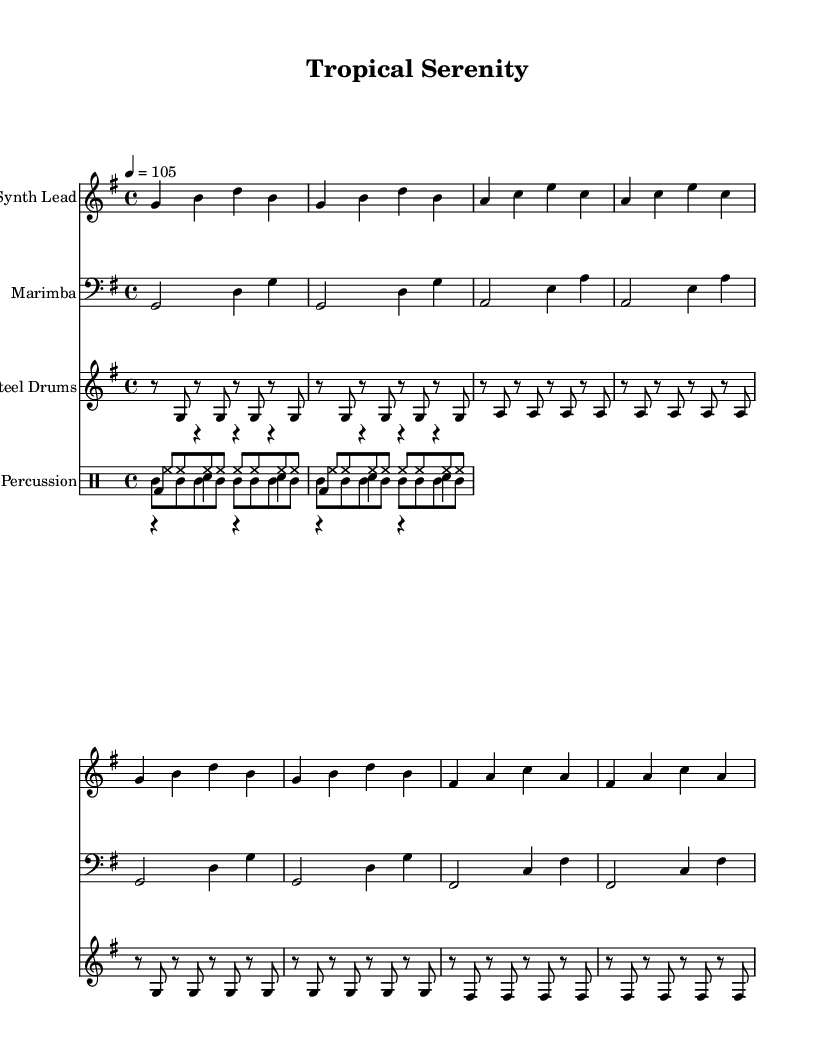What is the key signature of this music? The key signature is G major, which has one sharp (F-sharp). This can be determined by locating the key signature indicated at the beginning of the piece, right after the clef sign.
Answer: G major What is the time signature of this music? The time signature is 4/4, which is indicated at the start of the music after the key signature. This means there are four beats in each measure and the quarter note gets one beat.
Answer: 4/4 What is the tempo marking for this piece? The tempo marking is 4 = 105, which tells the performer to play at a speed of 105 beats per minute with a quarter note receiving one count. This is usually found near the beginning of the score.
Answer: 105 How many different instruments are indicated in this score? The music score has four distinct parts: Synth Lead, Marimba, Steel Drums, and Percussion. Each of these is written on a separate staff, which can be counted to reach the total number of instruments.
Answer: Four What rhythmic pattern is used for the kick drum? The kick drum pattern consists of a bass drum hit on the first beat of each measure followed by rests for the remaining three beats throughout the first two measures. This is determined by analyzing the written drummode section in the score.
Answer: Bass drum on first beat What is the instrument type of the melody line in this score? The melody line is assigned to a Synth Lead, which is indicated at the beginning of its staff. Synths are commonly used in tropical house music for melodic lines.
Answer: Synth Lead Which percussion instrument plays a constant eighth-note pattern? The hi-hat plays a constant eighth-note pattern throughout the measures, as indicated by the eighth note notation in the drummode for hi-hat. This provides a consistent rhythmic texture that is typical in dance music.
Answer: Hi-hat 